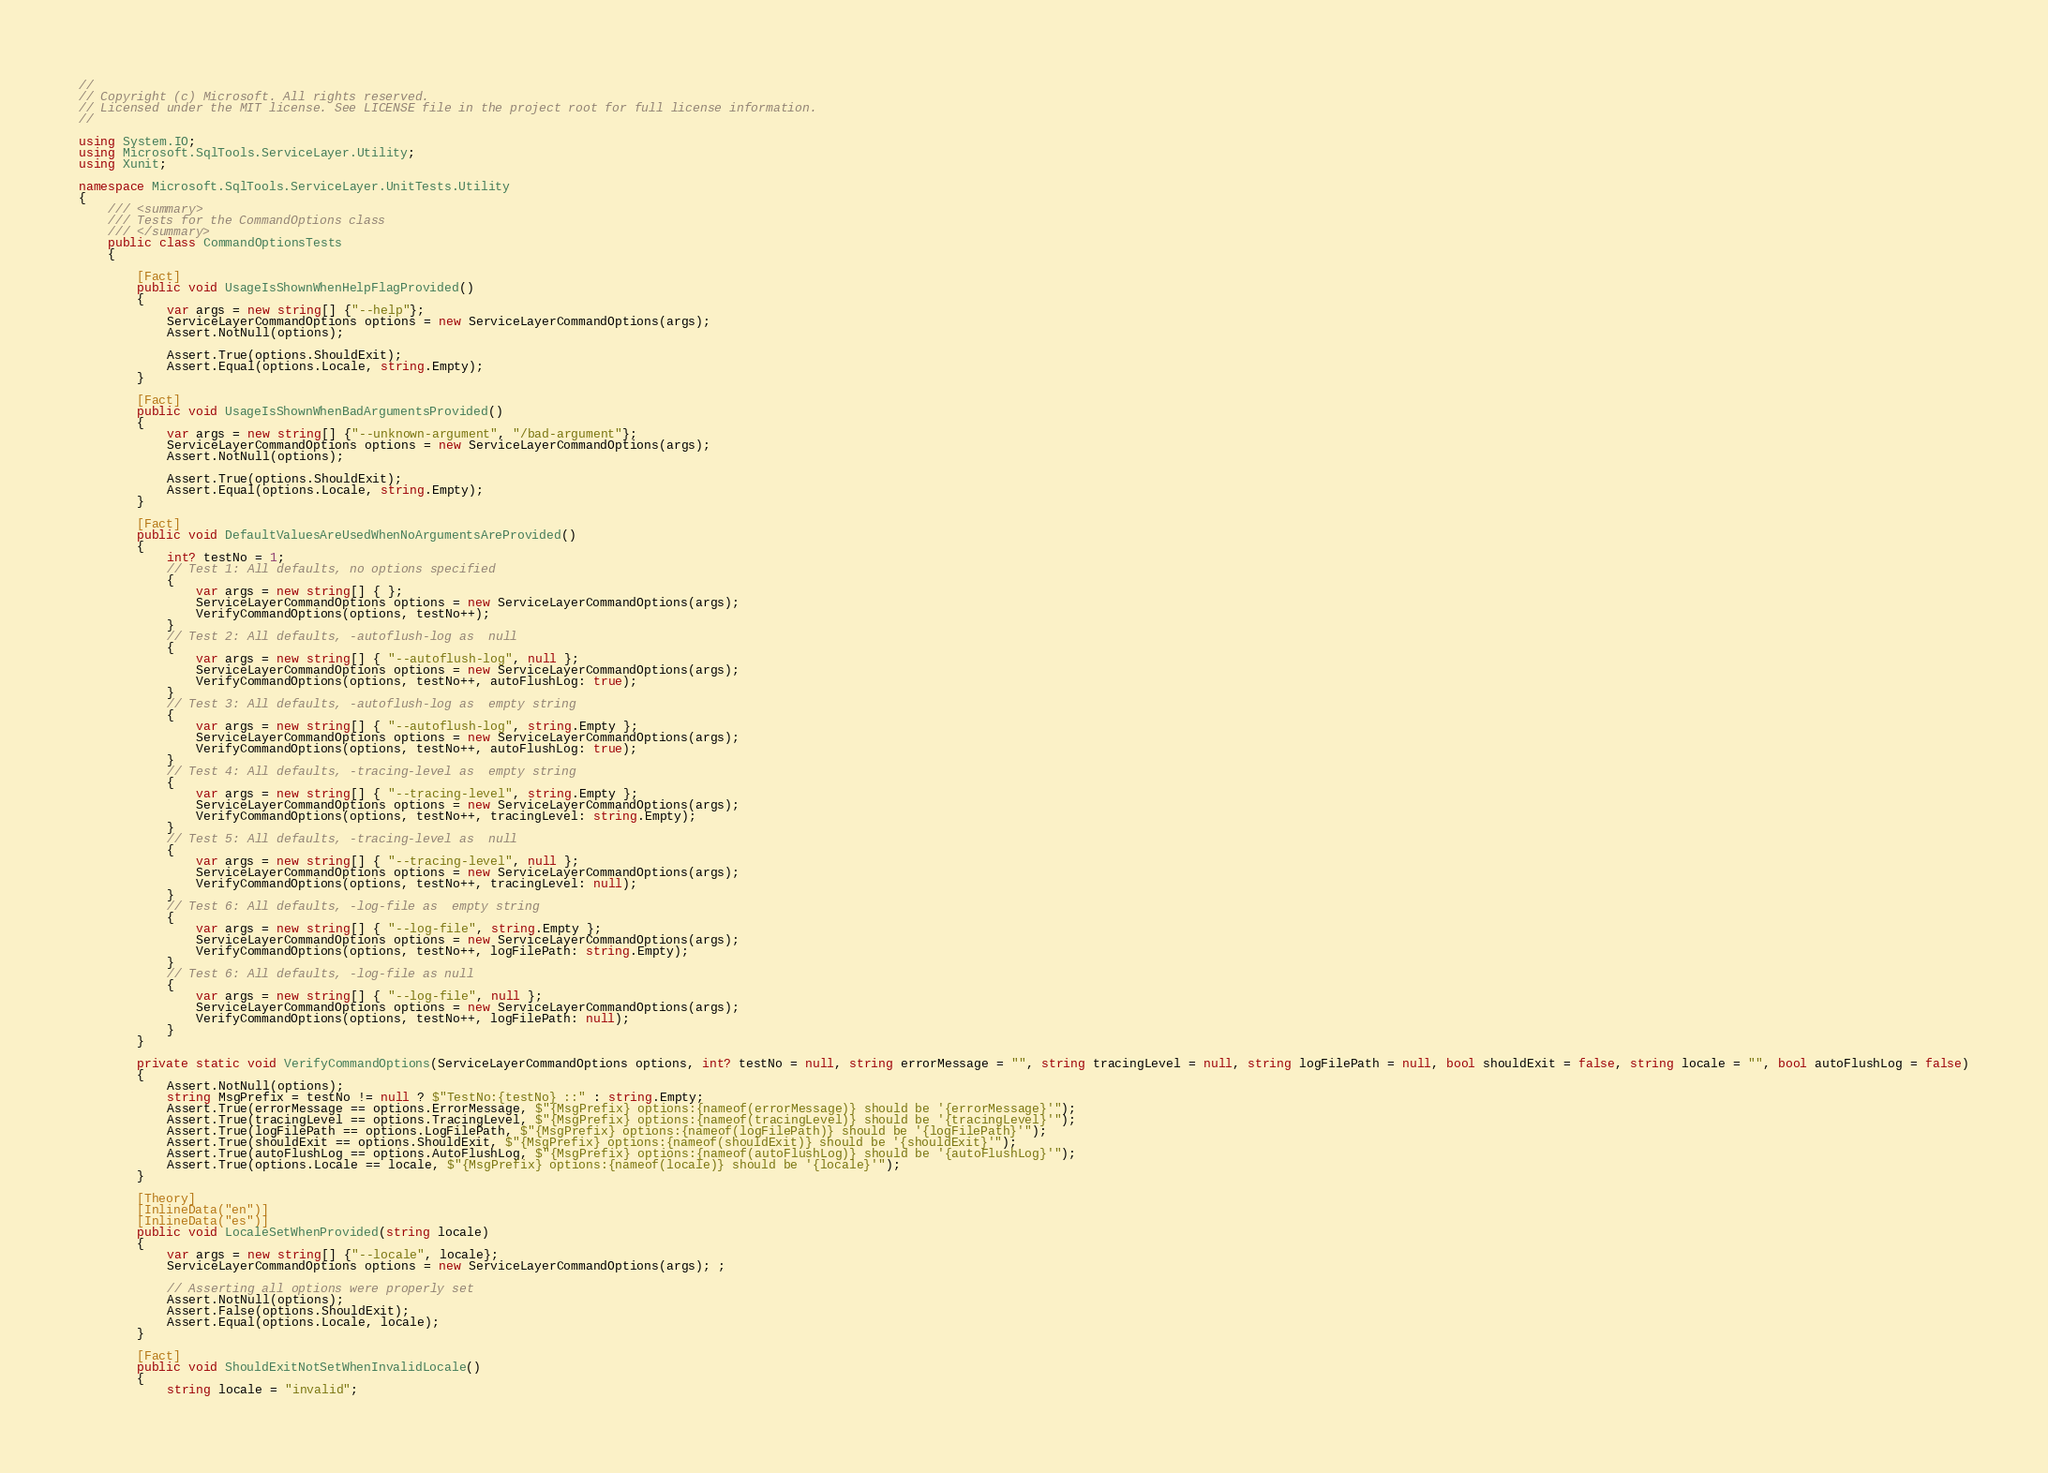<code> <loc_0><loc_0><loc_500><loc_500><_C#_>//
// Copyright (c) Microsoft. All rights reserved.
// Licensed under the MIT license. See LICENSE file in the project root for full license information.
//

using System.IO;
using Microsoft.SqlTools.ServiceLayer.Utility;
using Xunit;

namespace Microsoft.SqlTools.ServiceLayer.UnitTests.Utility
{
    /// <summary>
    /// Tests for the CommandOptions class
    /// </summary>
    public class CommandOptionsTests
    {

        [Fact]
        public void UsageIsShownWhenHelpFlagProvided()
        {
            var args = new string[] {"--help"};
            ServiceLayerCommandOptions options = new ServiceLayerCommandOptions(args);
            Assert.NotNull(options);

            Assert.True(options.ShouldExit);
            Assert.Equal(options.Locale, string.Empty);
        }

        [Fact]
        public void UsageIsShownWhenBadArgumentsProvided()
        {
            var args = new string[] {"--unknown-argument", "/bad-argument"};
            ServiceLayerCommandOptions options = new ServiceLayerCommandOptions(args);
            Assert.NotNull(options);

            Assert.True(options.ShouldExit);
            Assert.Equal(options.Locale, string.Empty);
        }

        [Fact]
        public void DefaultValuesAreUsedWhenNoArgumentsAreProvided()
        {
            int? testNo = 1;
            // Test 1: All defaults, no options specified
            {
                var args = new string[] { };
                ServiceLayerCommandOptions options = new ServiceLayerCommandOptions(args);
                VerifyCommandOptions(options, testNo++);
            }
            // Test 2: All defaults, -autoflush-log as  null 
            {
                var args = new string[] { "--autoflush-log", null };
                ServiceLayerCommandOptions options = new ServiceLayerCommandOptions(args);
                VerifyCommandOptions(options, testNo++, autoFlushLog: true);
            }
            // Test 3: All defaults, -autoflush-log as  empty string 
            {
                var args = new string[] { "--autoflush-log", string.Empty };
                ServiceLayerCommandOptions options = new ServiceLayerCommandOptions(args);
                VerifyCommandOptions(options, testNo++, autoFlushLog: true);
            }
            // Test 4: All defaults, -tracing-level as  empty string 
            {
                var args = new string[] { "--tracing-level", string.Empty };
                ServiceLayerCommandOptions options = new ServiceLayerCommandOptions(args);
                VerifyCommandOptions(options, testNo++, tracingLevel: string.Empty);
            }
            // Test 5: All defaults, -tracing-level as  null 
            {
                var args = new string[] { "--tracing-level", null };
                ServiceLayerCommandOptions options = new ServiceLayerCommandOptions(args);
                VerifyCommandOptions(options, testNo++, tracingLevel: null);
            }
            // Test 6: All defaults, -log-file as  empty string 
            {
                var args = new string[] { "--log-file", string.Empty };
                ServiceLayerCommandOptions options = new ServiceLayerCommandOptions(args);
                VerifyCommandOptions(options, testNo++, logFilePath: string.Empty);
            }
            // Test 6: All defaults, -log-file as null 
            {
                var args = new string[] { "--log-file", null };
                ServiceLayerCommandOptions options = new ServiceLayerCommandOptions(args);
                VerifyCommandOptions(options, testNo++, logFilePath: null);
            }
        }

        private static void VerifyCommandOptions(ServiceLayerCommandOptions options, int? testNo = null, string errorMessage = "", string tracingLevel = null, string logFilePath = null, bool shouldExit = false, string locale = "", bool autoFlushLog = false)
        {
            Assert.NotNull(options);
            string MsgPrefix = testNo != null ? $"TestNo:{testNo} ::" : string.Empty;
            Assert.True(errorMessage == options.ErrorMessage, $"{MsgPrefix} options:{nameof(errorMessage)} should be '{errorMessage}'");
            Assert.True(tracingLevel == options.TracingLevel, $"{MsgPrefix} options:{nameof(tracingLevel)} should be '{tracingLevel}'");
            Assert.True(logFilePath == options.LogFilePath, $"{MsgPrefix} options:{nameof(logFilePath)} should be '{logFilePath}'");
            Assert.True(shouldExit == options.ShouldExit, $"{MsgPrefix} options:{nameof(shouldExit)} should be '{shouldExit}'");
            Assert.True(autoFlushLog == options.AutoFlushLog, $"{MsgPrefix} options:{nameof(autoFlushLog)} should be '{autoFlushLog}'");
            Assert.True(options.Locale == locale, $"{MsgPrefix} options:{nameof(locale)} should be '{locale}'");
        }

        [Theory]
        [InlineData("en")]
        [InlineData("es")]
        public void LocaleSetWhenProvided(string locale)
        {
            var args = new string[] {"--locale", locale};
            ServiceLayerCommandOptions options = new ServiceLayerCommandOptions(args); ;

            // Asserting all options were properly set 
            Assert.NotNull(options);
            Assert.False(options.ShouldExit);
            Assert.Equal(options.Locale, locale);
        }

        [Fact]
        public void ShouldExitNotSetWhenInvalidLocale()
        {
            string locale = "invalid";</code> 